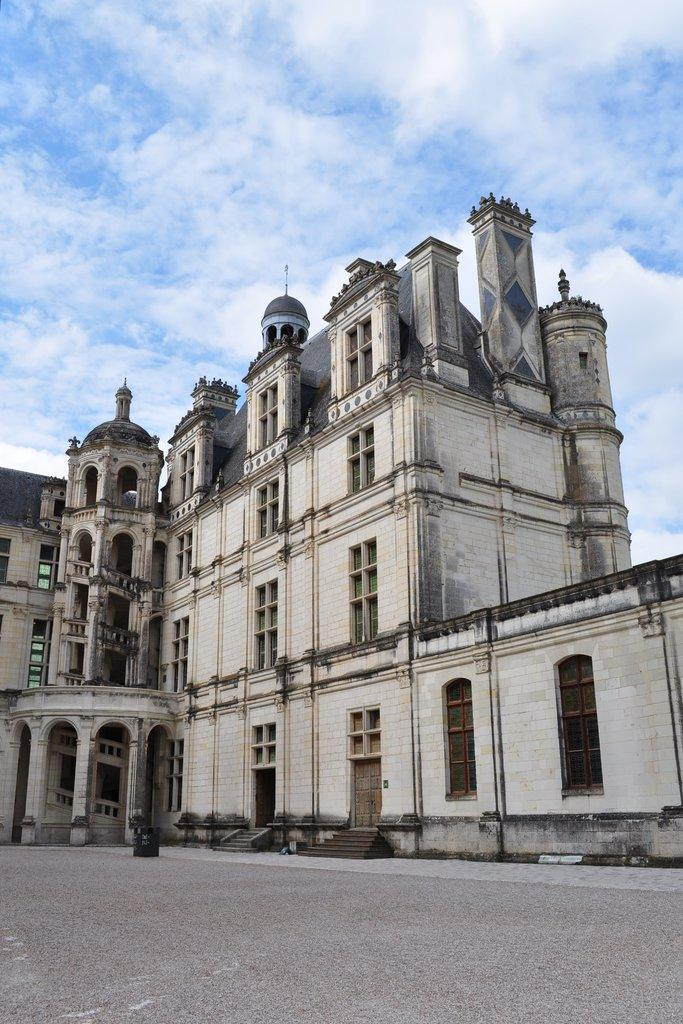What type of view is shown in the image? The image is an outside view. What can be seen at the bottom of the image? There is a road at the bottom of the image. What structure is located in the middle of the image? There is a building in the middle of the image. What is visible at the top of the image? The sky is visible at the top of the image. What can be observed in the sky? Clouds are present in the sky. What type of bead is used to decorate the desk in the image? There is no desk or bead present in the image. What type of needle can be seen sewing the clouds in the image? There is no needle or sewing activity depicted in the image; the clouds are naturally present in the sky. 